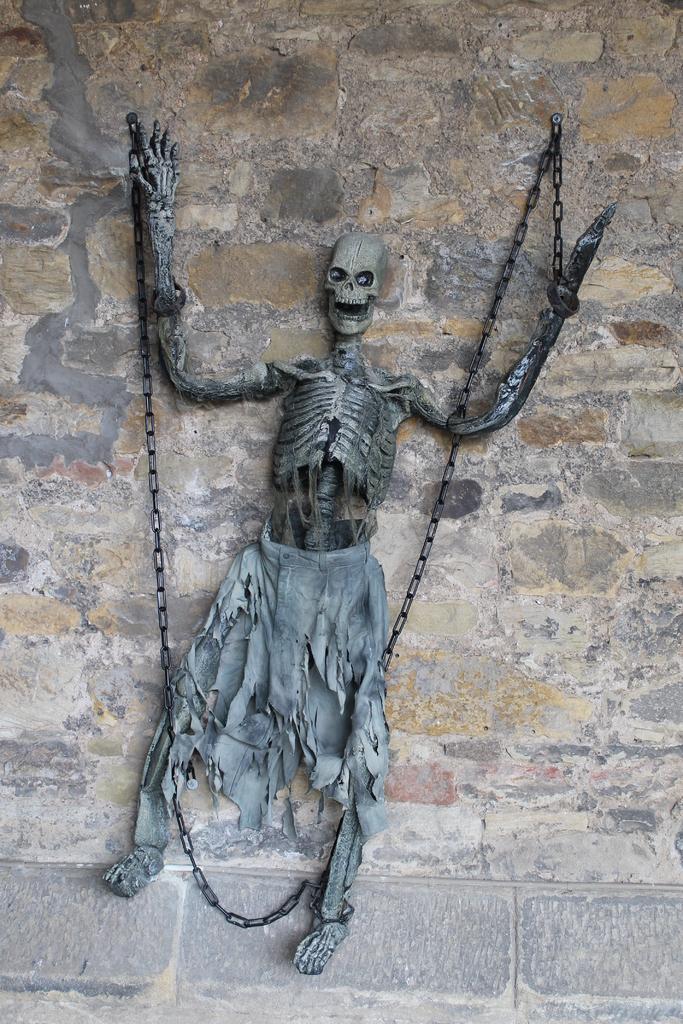Please provide a concise description of this image. In this image I can see the skeleton which is in grey color. And I can see the metal chain and the cloth to it. In the back I can see the wall. 